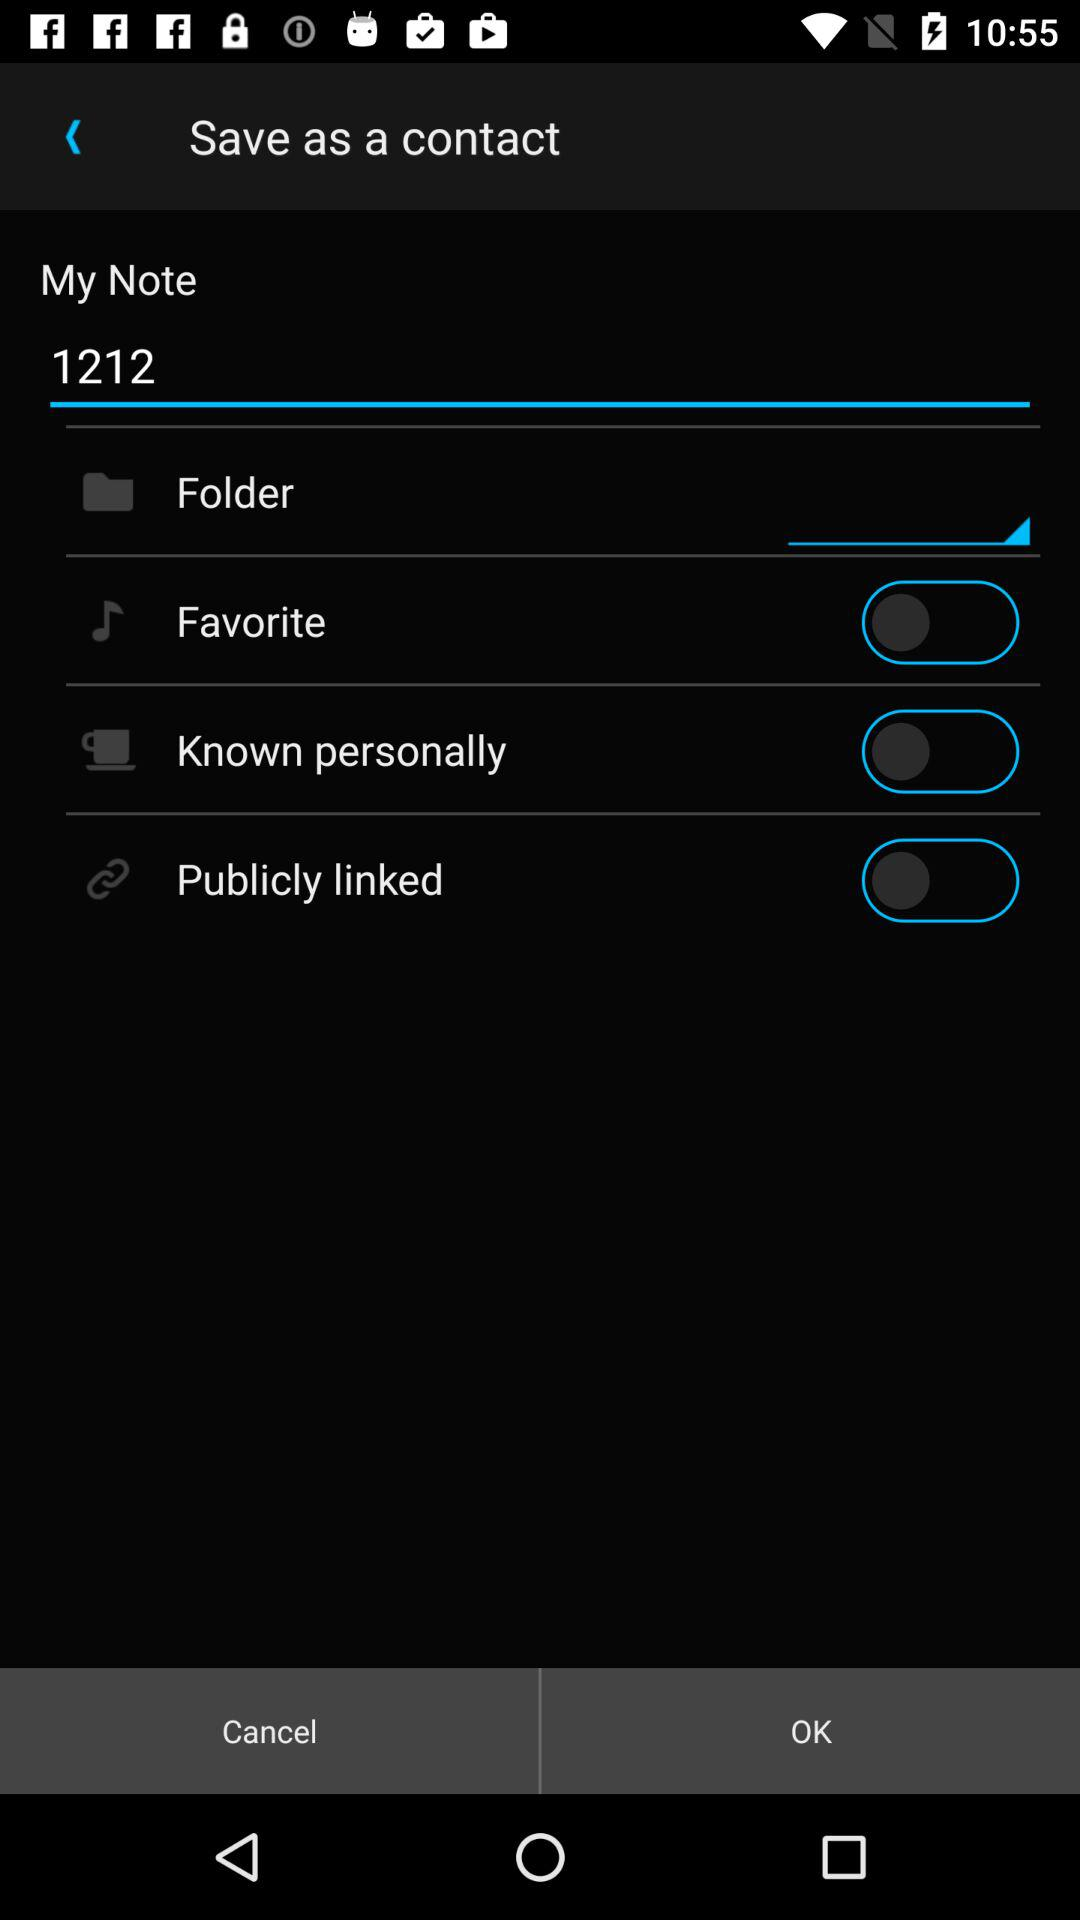What is the status of Folder?
When the provided information is insufficient, respond with <no answer>. <no answer> 